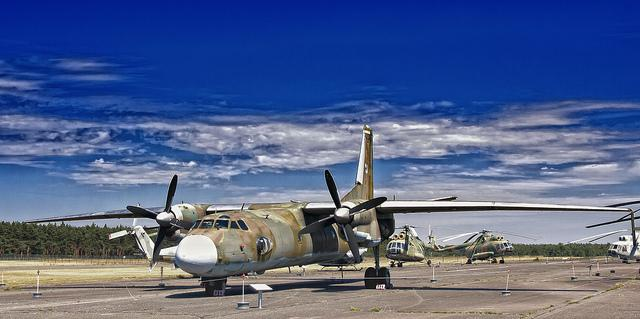What are the four things on each side of the vehicle called?

Choices:
A) missiles
B) propellers
C) windows
D) tires propellers 